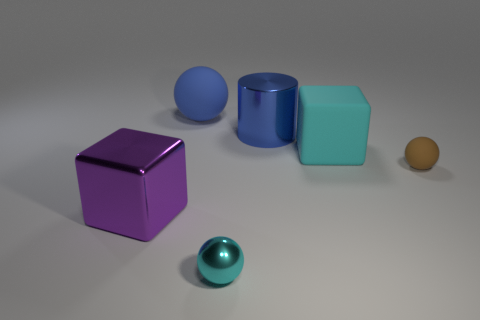What is the shape of the blue thing that is made of the same material as the tiny brown sphere?
Your answer should be compact. Sphere. Are there any other things of the same color as the metallic block?
Your answer should be compact. No. There is a large shiny cylinder; is it the same color as the matte thing behind the large metal cylinder?
Ensure brevity in your answer.  Yes. Is the number of tiny cyan metallic objects that are to the left of the small brown rubber sphere less than the number of big blue cylinders?
Your answer should be very brief. No. What is the tiny thing behind the purple thing made of?
Your response must be concise. Rubber. What number of other things are the same size as the blue rubber thing?
Your answer should be compact. 3. There is a blue sphere; does it have the same size as the cyan object in front of the big cyan cube?
Make the answer very short. No. What shape is the blue rubber thing that is behind the matte thing in front of the cyan object behind the purple object?
Your answer should be very brief. Sphere. Is the number of red matte balls less than the number of big things?
Keep it short and to the point. Yes. There is a blue shiny cylinder; are there any things right of it?
Ensure brevity in your answer.  Yes. 